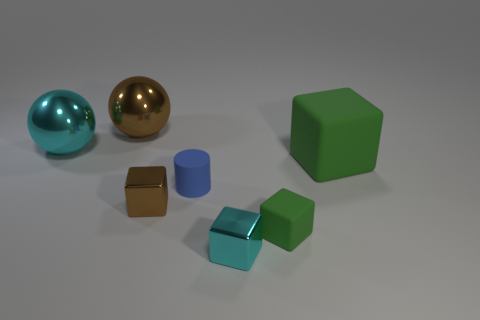Is the number of tiny brown shiny cubes that are behind the big cyan object less than the number of big matte cubes that are to the right of the small cyan metal cube? Upon inspection of the image, there is only one tiny brown shiny cube visible behind the large cyan geometric form. To the right of the small cyan metallic cube, there are two larger matte cubes. Therefore, the number of tiny brown shiny cubes behind the big cyan object is indeed less than the number of big matte cubes to the right of the small cyan metal cube. 